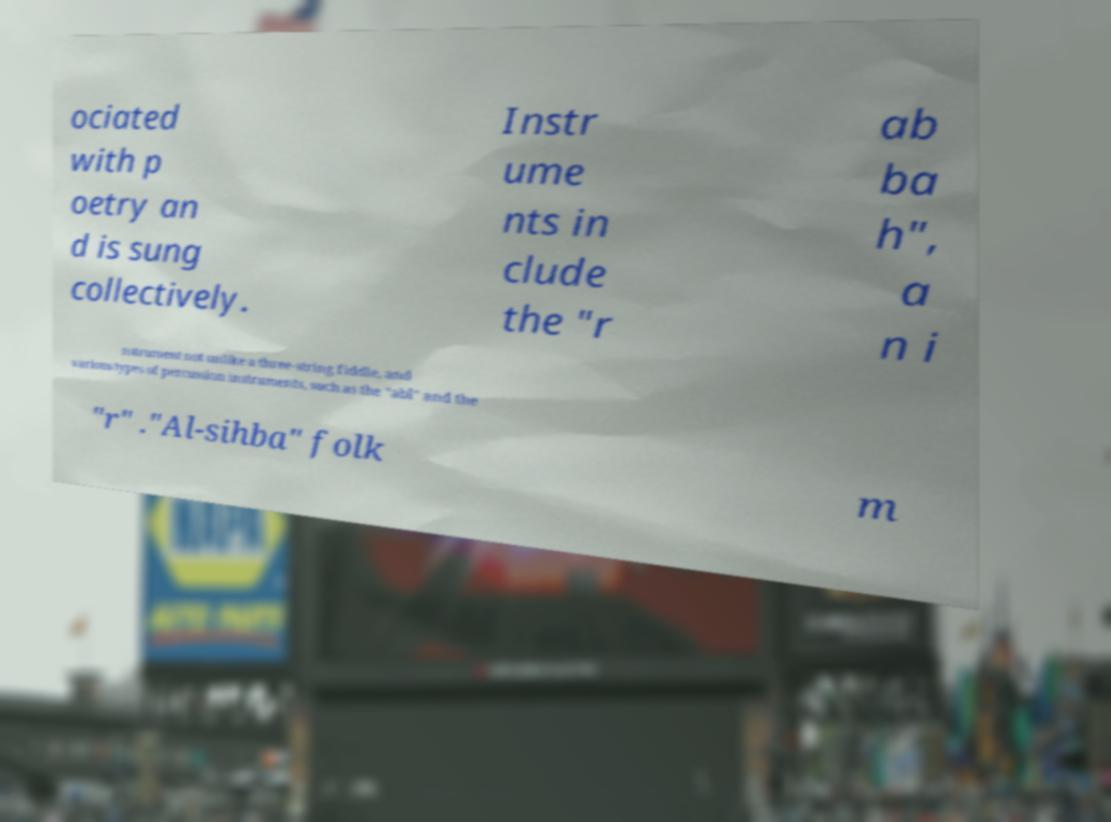For documentation purposes, I need the text within this image transcribed. Could you provide that? ociated with p oetry an d is sung collectively. Instr ume nts in clude the "r ab ba h", a n i nstrument not unlike a three-string fiddle, and various types of percussion instruments, such as the "abl" and the "r" ."Al-sihba" folk m 